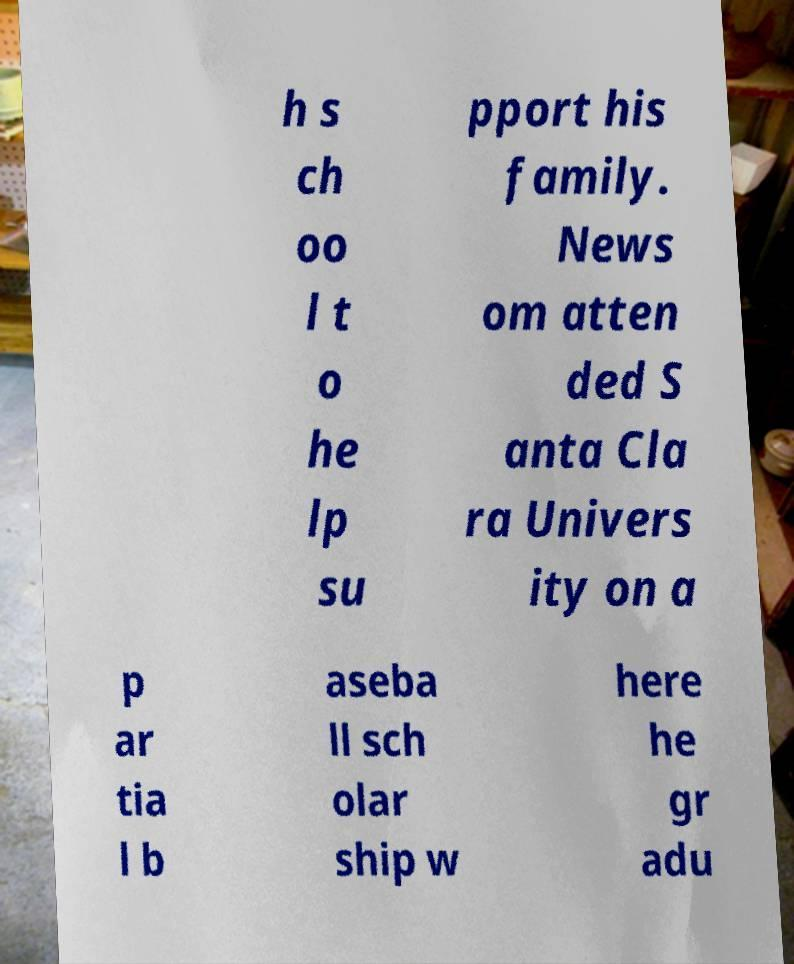For documentation purposes, I need the text within this image transcribed. Could you provide that? h s ch oo l t o he lp su pport his family. News om atten ded S anta Cla ra Univers ity on a p ar tia l b aseba ll sch olar ship w here he gr adu 